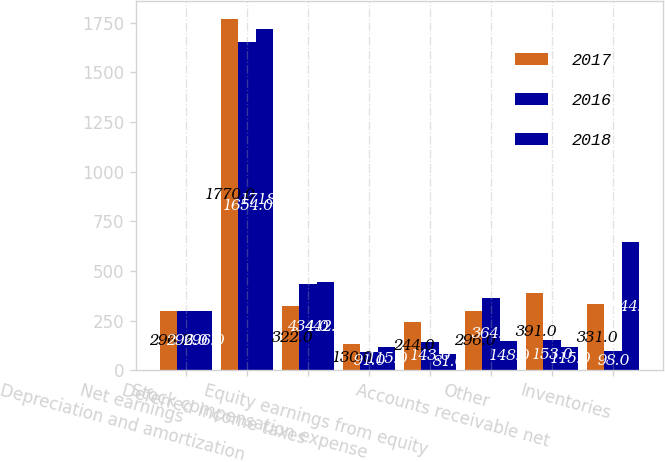Convert chart to OTSL. <chart><loc_0><loc_0><loc_500><loc_500><stacked_bar_chart><ecel><fcel>Net earnings<fcel>Depreciation and amortization<fcel>Deferred income taxes<fcel>Stock compensation expense<fcel>Equity earnings from equity<fcel>Other<fcel>Accounts receivable net<fcel>Inventories<nl><fcel>2017<fcel>296<fcel>1770<fcel>322<fcel>130<fcel>244<fcel>296<fcel>391<fcel>331<nl><fcel>2016<fcel>296<fcel>1654<fcel>434<fcel>91<fcel>143<fcel>364<fcel>153<fcel>98<nl><fcel>2018<fcel>296<fcel>1718<fcel>442<fcel>115<fcel>81<fcel>148<fcel>115<fcel>644<nl></chart> 